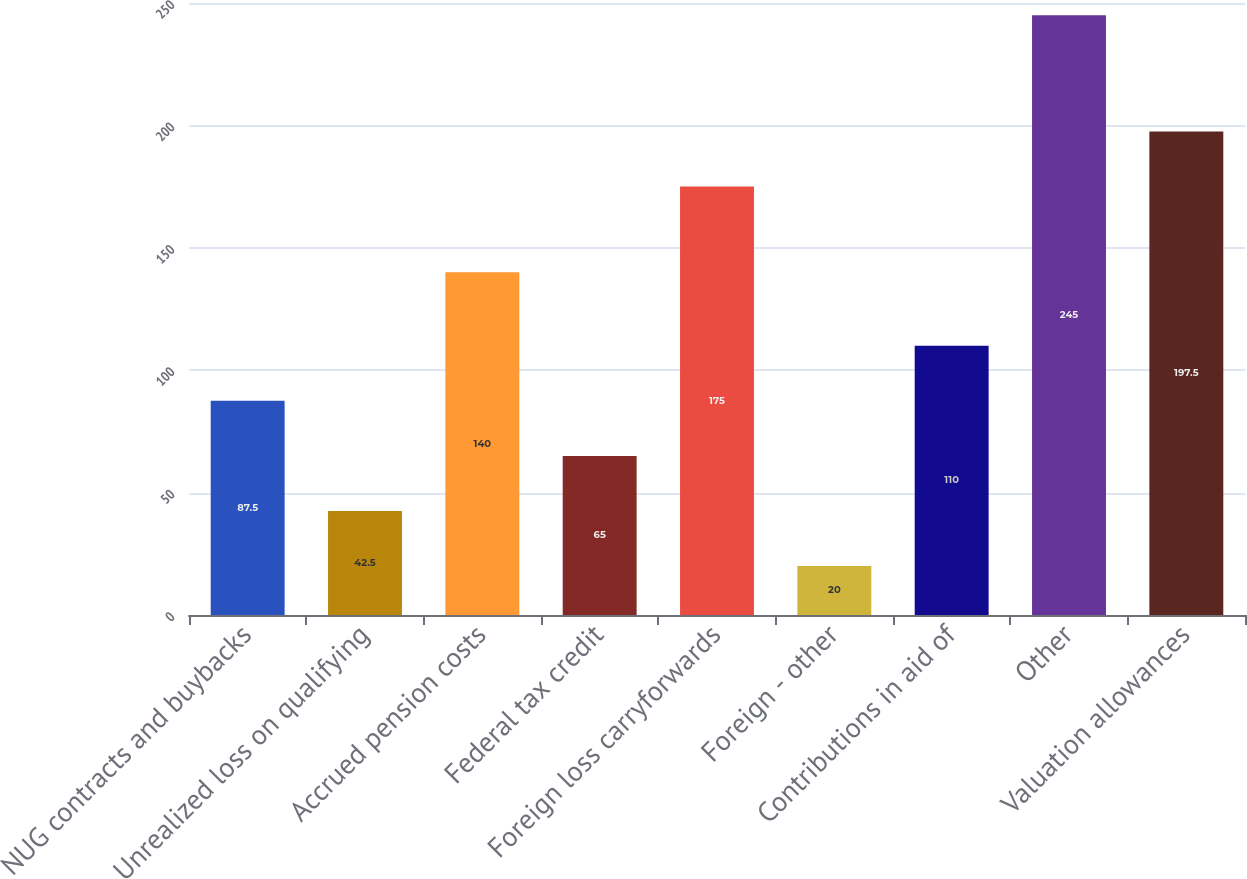Convert chart. <chart><loc_0><loc_0><loc_500><loc_500><bar_chart><fcel>NUG contracts and buybacks<fcel>Unrealized loss on qualifying<fcel>Accrued pension costs<fcel>Federal tax credit<fcel>Foreign loss carryforwards<fcel>Foreign - other<fcel>Contributions in aid of<fcel>Other<fcel>Valuation allowances<nl><fcel>87.5<fcel>42.5<fcel>140<fcel>65<fcel>175<fcel>20<fcel>110<fcel>245<fcel>197.5<nl></chart> 